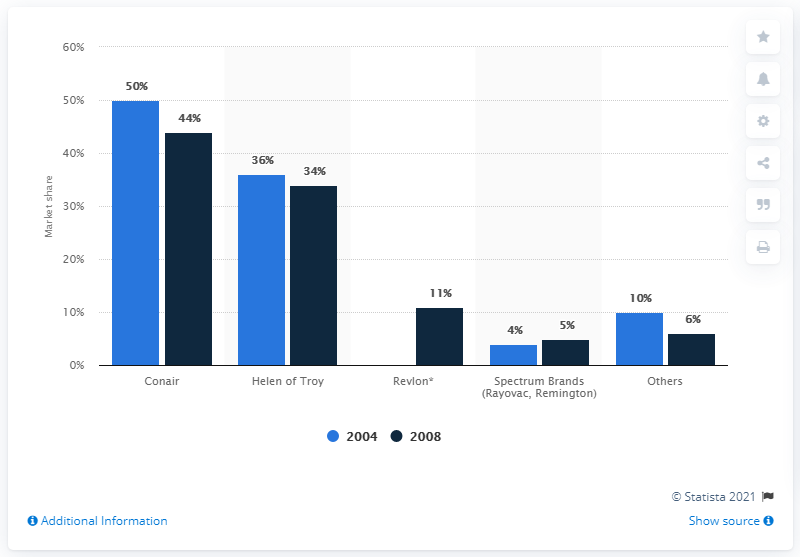Give some essential details in this illustration. Revlon's market share in 2004 and 2008 was approximately X% and X%, respectively. In 2008, Conair held a market share of 44% for hand-held hair dryers. In 2008, Revlon held approximately 11% of the market share in the beauty industry. 